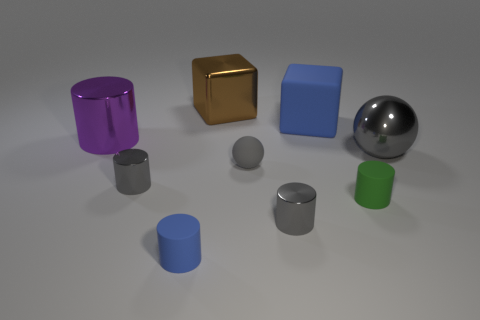Can you infer anything about the sizes of these objects relative to each other? Yes, the objects appear to be of varying sizes. For instance, the big blue cube looks considerably larger than the gold cube beside it. Similarly, the green cylinder is shorter than the purple cylinder, indicating a difference in both height and diameter. The shadows they cast also help to perceive their relative sizes and distances from each other. 